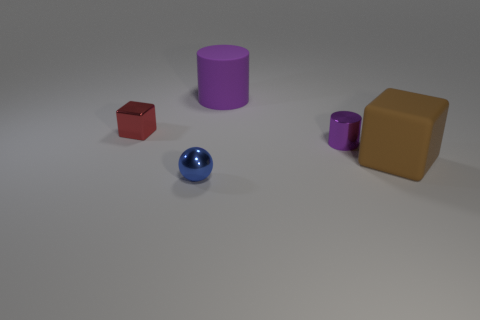There is a shiny object to the right of the big purple rubber thing; does it have the same shape as the big object in front of the tiny cylinder? No, the shiny object to the right of the large purple cylinder is spherical, whereas the large object in front of the tiny cylinder is a cube and hence they have different shapes. 